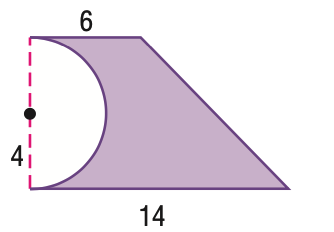Answer the mathemtical geometry problem and directly provide the correct option letter.
Question: Find the area of the figure.
Choices: A: 22.9 B: 29.7 C: 54.9 D: 60 C 